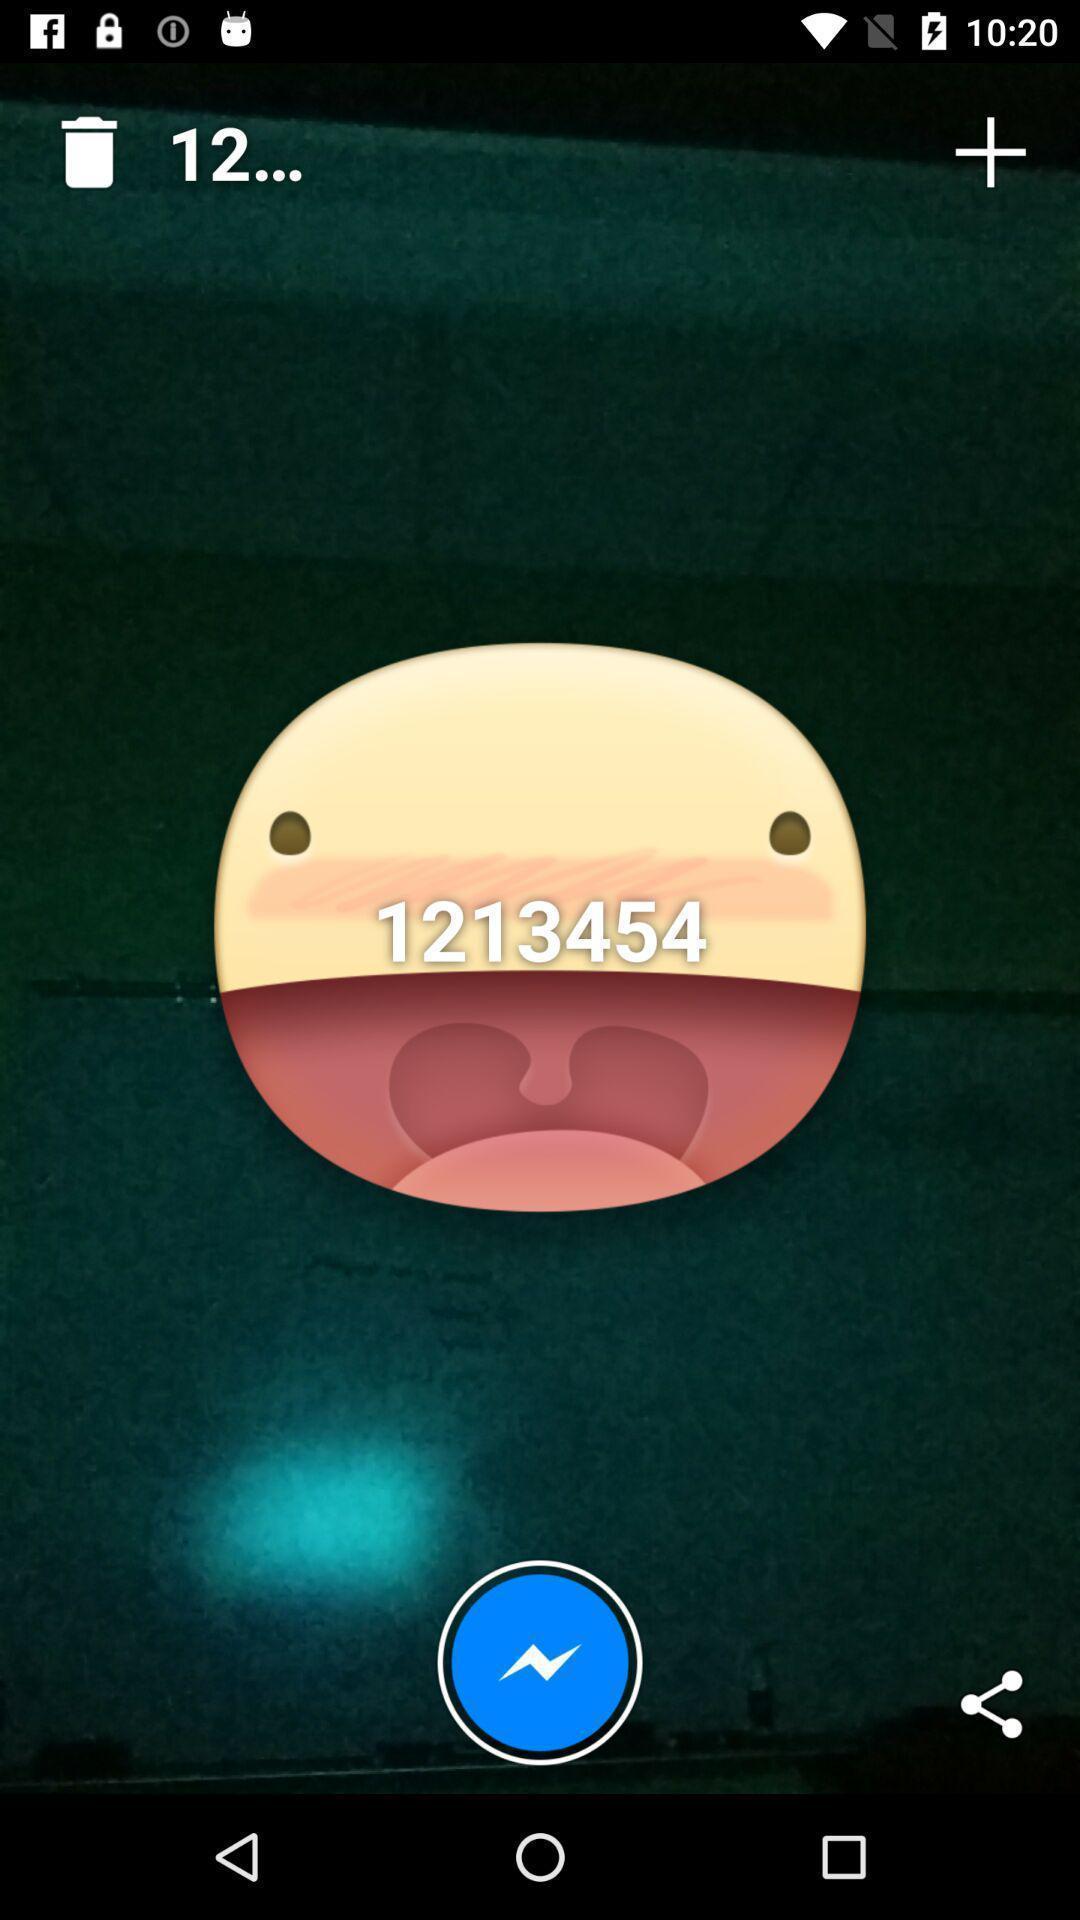Explain what's happening in this screen capture. Screen showing a sticker in a messenger app. 